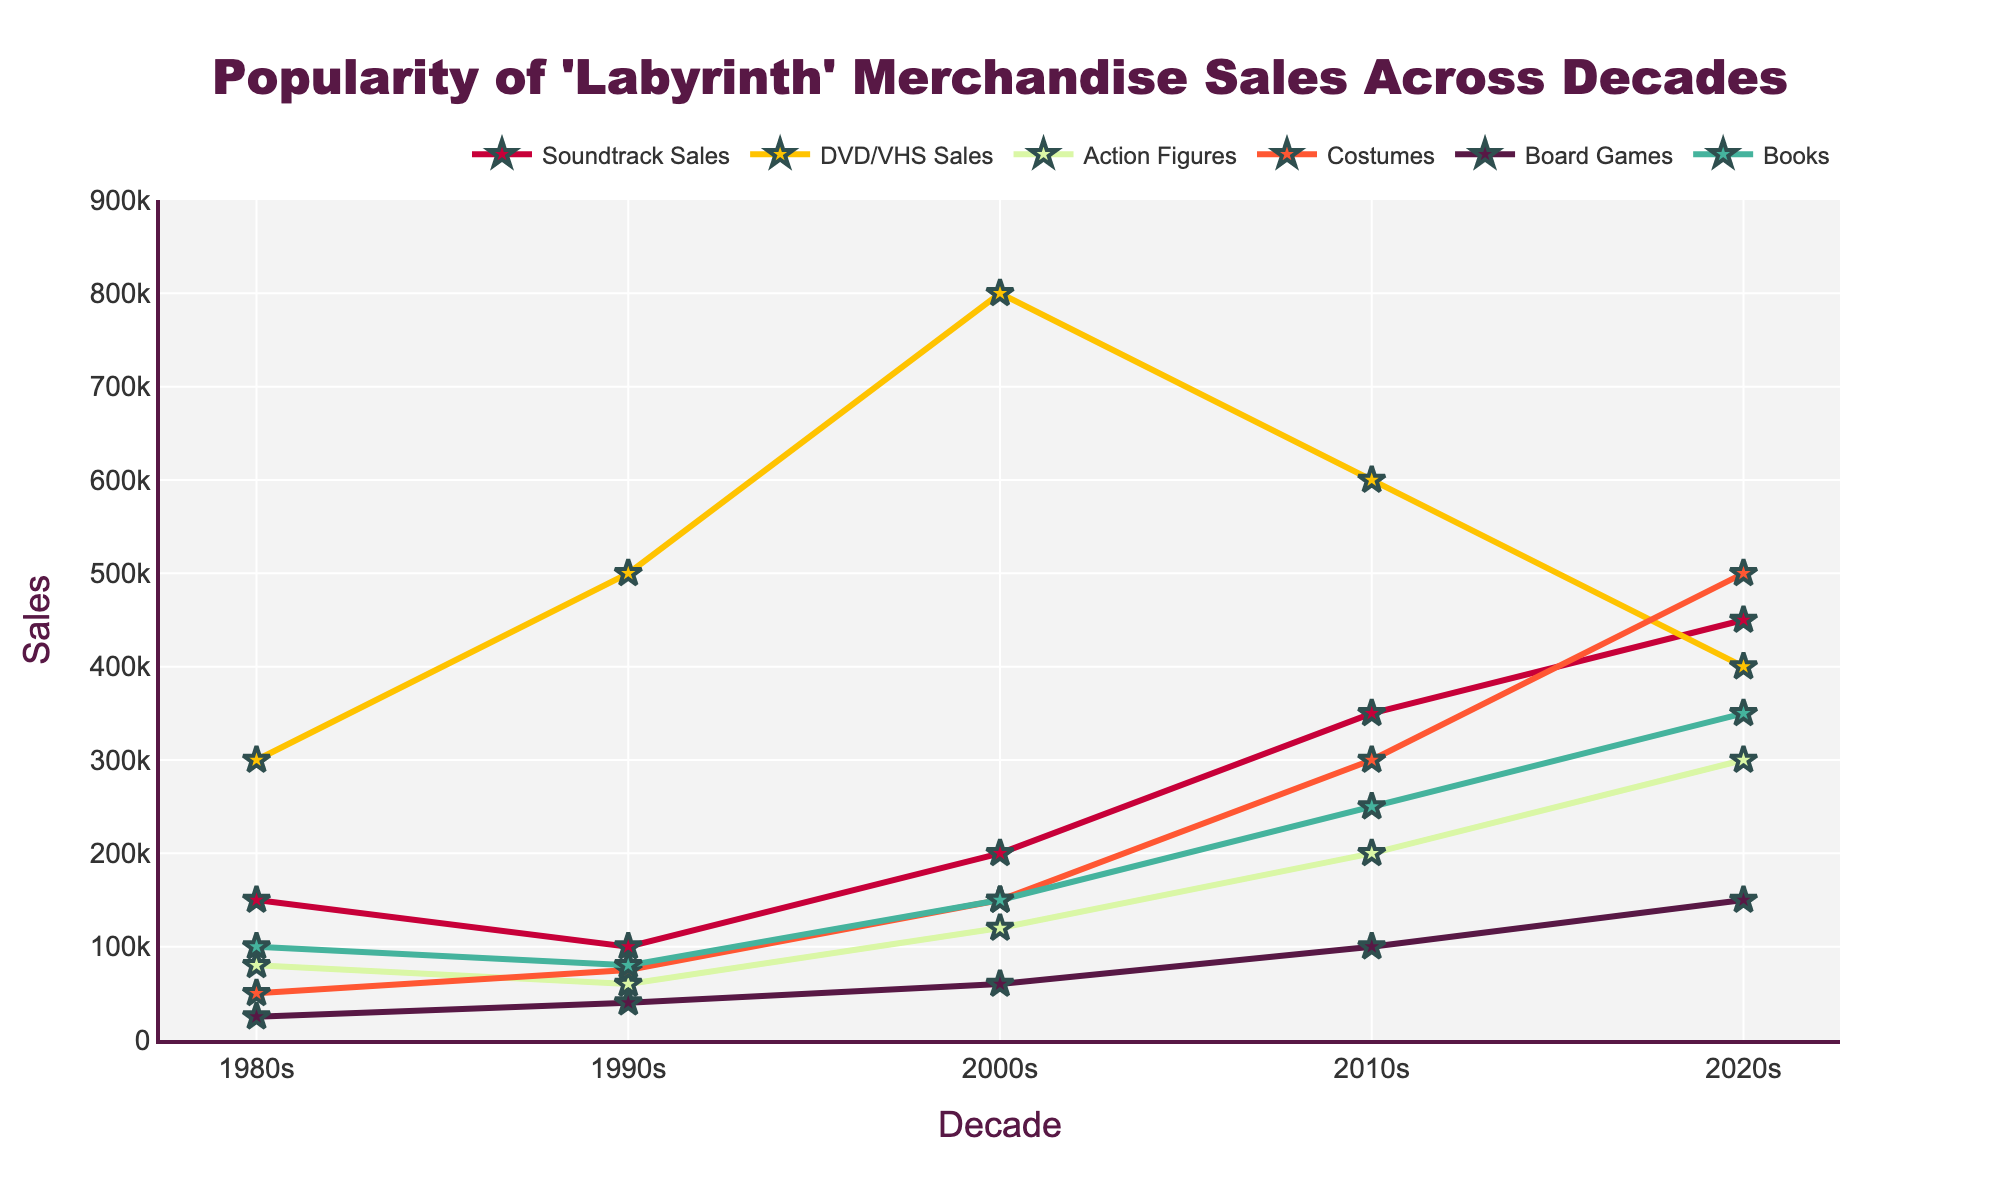Which decade had the highest costume sales? To determine which decade had the highest costume sales, look for the peak value in the "Costumes" category across all decades in the line chart. The highest value appears in the 2020s.
Answer: 2020s What is the difference in soundtrack sales between the 1990s and 2010s? Check the soundtrack sales for both the 1990s and the 2010s. In the 1990s, the sales are 100,000, and in the 2010s, the sales are 350,000. Subtract the 1990s value from the 2010s value: 350,000 - 100,000 = 250,000.
Answer: 250,000 How much more were DVD/VHS sales in the 2000s compared to the 1980s? Look for DVD/VHS sales numbers in both the 2000s and 1980s. For the 2000s, the sales are 800,000 and for the 1980s, the sales are 300,000. Subtract the 1980s value from the 2000s value: 800,000 - 300,000 = 500,000.
Answer: 500,000 Which category saw the most significant increase in sales from the 2010s to the 2020s? Compare the sales from the 2010s to the 2020s for each category and find the one with the highest difference. Board Games increased from 100,000 to 150,000 (50,000 increase), Books from 250,000 to 350,000 (100,000 increase), and so on. The biggest increase is for Costumes, from 300,000 to 500,000 (200,000 increase).
Answer: Costumes What was the total merchandise sales in the 2000s across all categories? Sum up the sales for all categories in the 2000s: Soundtrack (200,000), DVD/VHS (800,000), Action Figures (120,000), Costumes (150,000), Board Games (60,000), Books (150,000). The total is 200,000 + 800,000 + 120,000 + 150,000 + 60,000 + 150,000 = 1,480,000.
Answer: 1,480,000 Which category had the lowest sales in the 1980s? Look at the 1980s' sales figures for all the categories and identify the lowest value. Action Figures is 80,000, Costumes is 50,000, Board Games is 25,000, Books is 100,000, DVD/VHS is 300,000, and Soundtrack is 150,000. The lowest value is for Board Games at 25,000.
Answer: Board Games How did book sales change from the 1980s to the 2020s? Compare book sales in the 1980s and the 2020s. In the 1980s, book sales were 100,000, and in the 2020s, they rose to 350,000. The change is 350,000 - 100,000 = 250,000 increase.
Answer: 250,000 increase In which decade did action figures see the highest sales? Look at the highest sales value in the Action Figures category across all decades. In the 2020s, sales are 300,000, which appears to be the peak value.
Answer: 2020s 